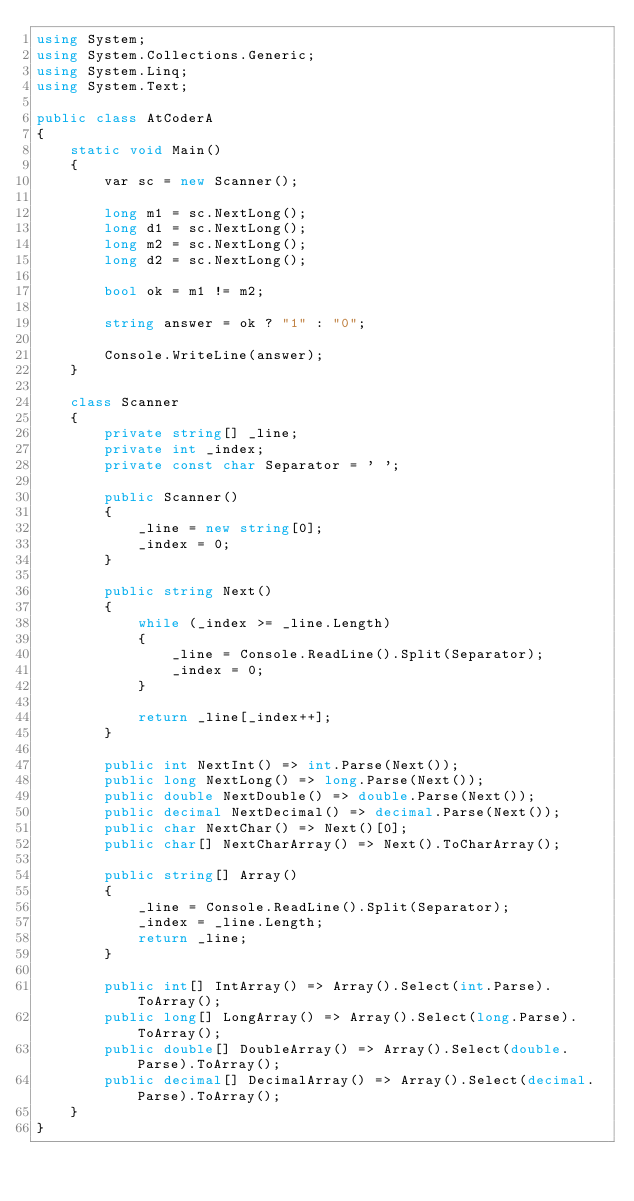<code> <loc_0><loc_0><loc_500><loc_500><_C#_>using System;
using System.Collections.Generic;
using System.Linq;
using System.Text;

public class AtCoderA
{
    static void Main()
    {
        var sc = new Scanner();

        long m1 = sc.NextLong();
        long d1 = sc.NextLong();
        long m2 = sc.NextLong();
        long d2 = sc.NextLong();

        bool ok = m1 != m2;

        string answer = ok ? "1" : "0";

        Console.WriteLine(answer);
    }

    class Scanner
    {
        private string[] _line;
        private int _index;
        private const char Separator = ' ';

        public Scanner()
        {
            _line = new string[0];
            _index = 0;
        }

        public string Next()
        {
            while (_index >= _line.Length)
            {
                _line = Console.ReadLine().Split(Separator);
                _index = 0;
            }

            return _line[_index++];
        }

        public int NextInt() => int.Parse(Next());
        public long NextLong() => long.Parse(Next());
        public double NextDouble() => double.Parse(Next());
        public decimal NextDecimal() => decimal.Parse(Next());
        public char NextChar() => Next()[0];
        public char[] NextCharArray() => Next().ToCharArray();

        public string[] Array()
        {
            _line = Console.ReadLine().Split(Separator);
            _index = _line.Length;
            return _line;
        }

        public int[] IntArray() => Array().Select(int.Parse).ToArray();
        public long[] LongArray() => Array().Select(long.Parse).ToArray();
        public double[] DoubleArray() => Array().Select(double.Parse).ToArray();
        public decimal[] DecimalArray() => Array().Select(decimal.Parse).ToArray();
    }
}
</code> 